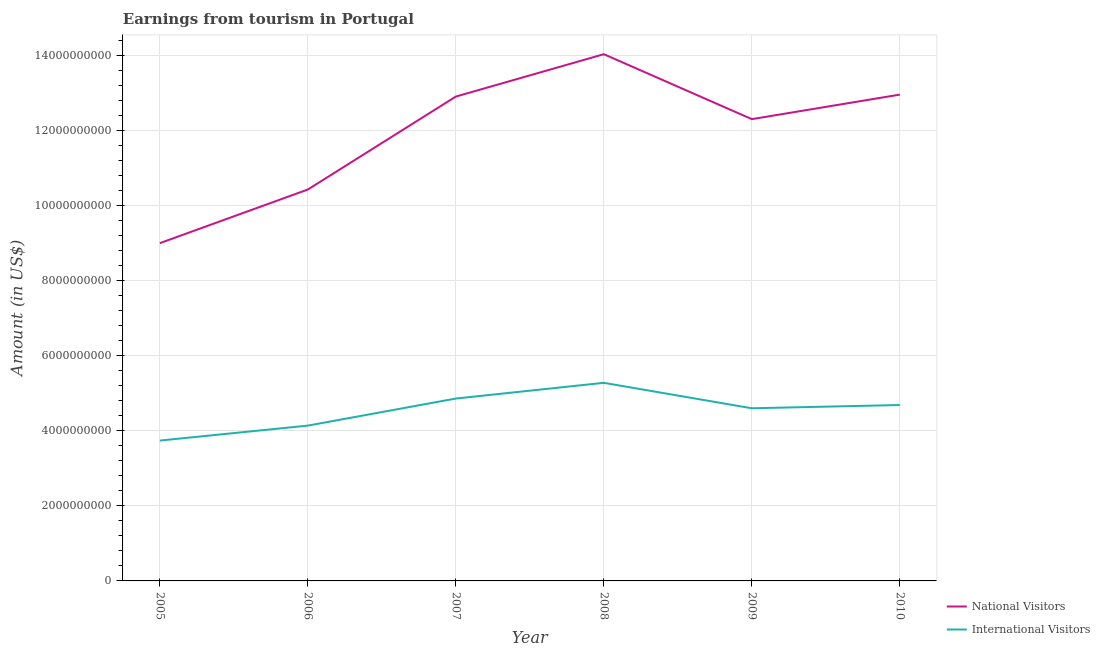Does the line corresponding to amount earned from national visitors intersect with the line corresponding to amount earned from international visitors?
Offer a terse response. No. Is the number of lines equal to the number of legend labels?
Offer a terse response. Yes. What is the amount earned from international visitors in 2006?
Your response must be concise. 4.14e+09. Across all years, what is the maximum amount earned from national visitors?
Your answer should be compact. 1.40e+1. Across all years, what is the minimum amount earned from international visitors?
Keep it short and to the point. 3.74e+09. In which year was the amount earned from international visitors maximum?
Your response must be concise. 2008. What is the total amount earned from national visitors in the graph?
Your answer should be compact. 7.17e+1. What is the difference between the amount earned from national visitors in 2005 and that in 2010?
Ensure brevity in your answer.  -3.96e+09. What is the difference between the amount earned from national visitors in 2006 and the amount earned from international visitors in 2008?
Make the answer very short. 5.16e+09. What is the average amount earned from national visitors per year?
Provide a short and direct response. 1.19e+1. In the year 2008, what is the difference between the amount earned from international visitors and amount earned from national visitors?
Offer a terse response. -8.76e+09. In how many years, is the amount earned from national visitors greater than 5200000000 US$?
Provide a succinct answer. 6. What is the ratio of the amount earned from international visitors in 2006 to that in 2010?
Keep it short and to the point. 0.88. What is the difference between the highest and the second highest amount earned from national visitors?
Provide a short and direct response. 1.08e+09. What is the difference between the highest and the lowest amount earned from national visitors?
Provide a short and direct response. 5.04e+09. Does the amount earned from international visitors monotonically increase over the years?
Keep it short and to the point. No. Is the amount earned from international visitors strictly greater than the amount earned from national visitors over the years?
Make the answer very short. No. How many lines are there?
Give a very brief answer. 2. How many years are there in the graph?
Your response must be concise. 6. Are the values on the major ticks of Y-axis written in scientific E-notation?
Your answer should be compact. No. Does the graph contain grids?
Offer a very short reply. Yes. Where does the legend appear in the graph?
Your answer should be compact. Bottom right. What is the title of the graph?
Your answer should be compact. Earnings from tourism in Portugal. Does "Primary school" appear as one of the legend labels in the graph?
Keep it short and to the point. No. What is the label or title of the X-axis?
Make the answer very short. Year. What is the Amount (in US$) of National Visitors in 2005?
Your answer should be compact. 9.01e+09. What is the Amount (in US$) in International Visitors in 2005?
Your answer should be very brief. 3.74e+09. What is the Amount (in US$) of National Visitors in 2006?
Keep it short and to the point. 1.04e+1. What is the Amount (in US$) in International Visitors in 2006?
Your answer should be compact. 4.14e+09. What is the Amount (in US$) in National Visitors in 2007?
Provide a short and direct response. 1.29e+1. What is the Amount (in US$) in International Visitors in 2007?
Provide a succinct answer. 4.86e+09. What is the Amount (in US$) in National Visitors in 2008?
Keep it short and to the point. 1.40e+1. What is the Amount (in US$) of International Visitors in 2008?
Provide a short and direct response. 5.28e+09. What is the Amount (in US$) of National Visitors in 2009?
Your answer should be very brief. 1.23e+1. What is the Amount (in US$) in International Visitors in 2009?
Your answer should be very brief. 4.60e+09. What is the Amount (in US$) of National Visitors in 2010?
Make the answer very short. 1.30e+1. What is the Amount (in US$) of International Visitors in 2010?
Make the answer very short. 4.69e+09. Across all years, what is the maximum Amount (in US$) in National Visitors?
Keep it short and to the point. 1.40e+1. Across all years, what is the maximum Amount (in US$) in International Visitors?
Offer a very short reply. 5.28e+09. Across all years, what is the minimum Amount (in US$) in National Visitors?
Your response must be concise. 9.01e+09. Across all years, what is the minimum Amount (in US$) of International Visitors?
Give a very brief answer. 3.74e+09. What is the total Amount (in US$) of National Visitors in the graph?
Keep it short and to the point. 7.17e+1. What is the total Amount (in US$) in International Visitors in the graph?
Offer a very short reply. 2.73e+1. What is the difference between the Amount (in US$) of National Visitors in 2005 and that in 2006?
Your answer should be compact. -1.43e+09. What is the difference between the Amount (in US$) in International Visitors in 2005 and that in 2006?
Ensure brevity in your answer.  -3.99e+08. What is the difference between the Amount (in US$) of National Visitors in 2005 and that in 2007?
Your response must be concise. -3.91e+09. What is the difference between the Amount (in US$) in International Visitors in 2005 and that in 2007?
Give a very brief answer. -1.12e+09. What is the difference between the Amount (in US$) of National Visitors in 2005 and that in 2008?
Offer a very short reply. -5.04e+09. What is the difference between the Amount (in US$) in International Visitors in 2005 and that in 2008?
Provide a succinct answer. -1.54e+09. What is the difference between the Amount (in US$) of National Visitors in 2005 and that in 2009?
Offer a terse response. -3.31e+09. What is the difference between the Amount (in US$) of International Visitors in 2005 and that in 2009?
Your answer should be very brief. -8.61e+08. What is the difference between the Amount (in US$) of National Visitors in 2005 and that in 2010?
Provide a short and direct response. -3.96e+09. What is the difference between the Amount (in US$) in International Visitors in 2005 and that in 2010?
Make the answer very short. -9.48e+08. What is the difference between the Amount (in US$) of National Visitors in 2006 and that in 2007?
Your answer should be very brief. -2.48e+09. What is the difference between the Amount (in US$) of International Visitors in 2006 and that in 2007?
Ensure brevity in your answer.  -7.22e+08. What is the difference between the Amount (in US$) of National Visitors in 2006 and that in 2008?
Provide a short and direct response. -3.61e+09. What is the difference between the Amount (in US$) in International Visitors in 2006 and that in 2008?
Make the answer very short. -1.14e+09. What is the difference between the Amount (in US$) of National Visitors in 2006 and that in 2009?
Provide a short and direct response. -1.88e+09. What is the difference between the Amount (in US$) in International Visitors in 2006 and that in 2009?
Ensure brevity in your answer.  -4.62e+08. What is the difference between the Amount (in US$) in National Visitors in 2006 and that in 2010?
Offer a terse response. -2.53e+09. What is the difference between the Amount (in US$) in International Visitors in 2006 and that in 2010?
Give a very brief answer. -5.49e+08. What is the difference between the Amount (in US$) of National Visitors in 2007 and that in 2008?
Your answer should be very brief. -1.13e+09. What is the difference between the Amount (in US$) of International Visitors in 2007 and that in 2008?
Keep it short and to the point. -4.19e+08. What is the difference between the Amount (in US$) in National Visitors in 2007 and that in 2009?
Offer a very short reply. 6.02e+08. What is the difference between the Amount (in US$) in International Visitors in 2007 and that in 2009?
Provide a succinct answer. 2.60e+08. What is the difference between the Amount (in US$) in National Visitors in 2007 and that in 2010?
Provide a short and direct response. -5.20e+07. What is the difference between the Amount (in US$) of International Visitors in 2007 and that in 2010?
Provide a succinct answer. 1.73e+08. What is the difference between the Amount (in US$) in National Visitors in 2008 and that in 2009?
Give a very brief answer. 1.73e+09. What is the difference between the Amount (in US$) in International Visitors in 2008 and that in 2009?
Provide a short and direct response. 6.79e+08. What is the difference between the Amount (in US$) of National Visitors in 2008 and that in 2010?
Your answer should be very brief. 1.08e+09. What is the difference between the Amount (in US$) in International Visitors in 2008 and that in 2010?
Provide a succinct answer. 5.92e+08. What is the difference between the Amount (in US$) of National Visitors in 2009 and that in 2010?
Ensure brevity in your answer.  -6.54e+08. What is the difference between the Amount (in US$) in International Visitors in 2009 and that in 2010?
Your answer should be very brief. -8.70e+07. What is the difference between the Amount (in US$) of National Visitors in 2005 and the Amount (in US$) of International Visitors in 2006?
Your answer should be compact. 4.87e+09. What is the difference between the Amount (in US$) in National Visitors in 2005 and the Amount (in US$) in International Visitors in 2007?
Make the answer very short. 4.14e+09. What is the difference between the Amount (in US$) of National Visitors in 2005 and the Amount (in US$) of International Visitors in 2008?
Provide a short and direct response. 3.72e+09. What is the difference between the Amount (in US$) in National Visitors in 2005 and the Amount (in US$) in International Visitors in 2009?
Your answer should be compact. 4.40e+09. What is the difference between the Amount (in US$) of National Visitors in 2005 and the Amount (in US$) of International Visitors in 2010?
Provide a short and direct response. 4.32e+09. What is the difference between the Amount (in US$) in National Visitors in 2006 and the Amount (in US$) in International Visitors in 2007?
Ensure brevity in your answer.  5.57e+09. What is the difference between the Amount (in US$) of National Visitors in 2006 and the Amount (in US$) of International Visitors in 2008?
Keep it short and to the point. 5.16e+09. What is the difference between the Amount (in US$) in National Visitors in 2006 and the Amount (in US$) in International Visitors in 2009?
Give a very brief answer. 5.83e+09. What is the difference between the Amount (in US$) of National Visitors in 2006 and the Amount (in US$) of International Visitors in 2010?
Your answer should be compact. 5.75e+09. What is the difference between the Amount (in US$) in National Visitors in 2007 and the Amount (in US$) in International Visitors in 2008?
Offer a terse response. 7.63e+09. What is the difference between the Amount (in US$) of National Visitors in 2007 and the Amount (in US$) of International Visitors in 2009?
Provide a succinct answer. 8.31e+09. What is the difference between the Amount (in US$) in National Visitors in 2007 and the Amount (in US$) in International Visitors in 2010?
Ensure brevity in your answer.  8.23e+09. What is the difference between the Amount (in US$) in National Visitors in 2008 and the Amount (in US$) in International Visitors in 2009?
Provide a short and direct response. 9.44e+09. What is the difference between the Amount (in US$) in National Visitors in 2008 and the Amount (in US$) in International Visitors in 2010?
Give a very brief answer. 9.36e+09. What is the difference between the Amount (in US$) of National Visitors in 2009 and the Amount (in US$) of International Visitors in 2010?
Give a very brief answer. 7.62e+09. What is the average Amount (in US$) of National Visitors per year?
Your answer should be compact. 1.19e+1. What is the average Amount (in US$) in International Visitors per year?
Provide a short and direct response. 4.55e+09. In the year 2005, what is the difference between the Amount (in US$) of National Visitors and Amount (in US$) of International Visitors?
Make the answer very short. 5.26e+09. In the year 2006, what is the difference between the Amount (in US$) in National Visitors and Amount (in US$) in International Visitors?
Keep it short and to the point. 6.30e+09. In the year 2007, what is the difference between the Amount (in US$) in National Visitors and Amount (in US$) in International Visitors?
Ensure brevity in your answer.  8.05e+09. In the year 2008, what is the difference between the Amount (in US$) in National Visitors and Amount (in US$) in International Visitors?
Your response must be concise. 8.76e+09. In the year 2009, what is the difference between the Amount (in US$) in National Visitors and Amount (in US$) in International Visitors?
Offer a very short reply. 7.71e+09. In the year 2010, what is the difference between the Amount (in US$) in National Visitors and Amount (in US$) in International Visitors?
Give a very brief answer. 8.28e+09. What is the ratio of the Amount (in US$) in National Visitors in 2005 to that in 2006?
Provide a succinct answer. 0.86. What is the ratio of the Amount (in US$) in International Visitors in 2005 to that in 2006?
Ensure brevity in your answer.  0.9. What is the ratio of the Amount (in US$) of National Visitors in 2005 to that in 2007?
Give a very brief answer. 0.7. What is the ratio of the Amount (in US$) in International Visitors in 2005 to that in 2007?
Provide a succinct answer. 0.77. What is the ratio of the Amount (in US$) of National Visitors in 2005 to that in 2008?
Provide a succinct answer. 0.64. What is the ratio of the Amount (in US$) of International Visitors in 2005 to that in 2008?
Keep it short and to the point. 0.71. What is the ratio of the Amount (in US$) in National Visitors in 2005 to that in 2009?
Your response must be concise. 0.73. What is the ratio of the Amount (in US$) in International Visitors in 2005 to that in 2009?
Provide a short and direct response. 0.81. What is the ratio of the Amount (in US$) in National Visitors in 2005 to that in 2010?
Provide a succinct answer. 0.69. What is the ratio of the Amount (in US$) of International Visitors in 2005 to that in 2010?
Offer a terse response. 0.8. What is the ratio of the Amount (in US$) of National Visitors in 2006 to that in 2007?
Keep it short and to the point. 0.81. What is the ratio of the Amount (in US$) in International Visitors in 2006 to that in 2007?
Provide a succinct answer. 0.85. What is the ratio of the Amount (in US$) of National Visitors in 2006 to that in 2008?
Your answer should be compact. 0.74. What is the ratio of the Amount (in US$) in International Visitors in 2006 to that in 2008?
Make the answer very short. 0.78. What is the ratio of the Amount (in US$) in National Visitors in 2006 to that in 2009?
Offer a terse response. 0.85. What is the ratio of the Amount (in US$) of International Visitors in 2006 to that in 2009?
Provide a short and direct response. 0.9. What is the ratio of the Amount (in US$) in National Visitors in 2006 to that in 2010?
Your answer should be compact. 0.8. What is the ratio of the Amount (in US$) of International Visitors in 2006 to that in 2010?
Give a very brief answer. 0.88. What is the ratio of the Amount (in US$) of National Visitors in 2007 to that in 2008?
Make the answer very short. 0.92. What is the ratio of the Amount (in US$) of International Visitors in 2007 to that in 2008?
Offer a very short reply. 0.92. What is the ratio of the Amount (in US$) of National Visitors in 2007 to that in 2009?
Your answer should be compact. 1.05. What is the ratio of the Amount (in US$) of International Visitors in 2007 to that in 2009?
Offer a terse response. 1.06. What is the ratio of the Amount (in US$) in National Visitors in 2007 to that in 2010?
Give a very brief answer. 1. What is the ratio of the Amount (in US$) in International Visitors in 2007 to that in 2010?
Your response must be concise. 1.04. What is the ratio of the Amount (in US$) in National Visitors in 2008 to that in 2009?
Offer a very short reply. 1.14. What is the ratio of the Amount (in US$) in International Visitors in 2008 to that in 2009?
Ensure brevity in your answer.  1.15. What is the ratio of the Amount (in US$) of National Visitors in 2008 to that in 2010?
Your response must be concise. 1.08. What is the ratio of the Amount (in US$) of International Visitors in 2008 to that in 2010?
Your answer should be compact. 1.13. What is the ratio of the Amount (in US$) in National Visitors in 2009 to that in 2010?
Offer a terse response. 0.95. What is the ratio of the Amount (in US$) in International Visitors in 2009 to that in 2010?
Keep it short and to the point. 0.98. What is the difference between the highest and the second highest Amount (in US$) in National Visitors?
Make the answer very short. 1.08e+09. What is the difference between the highest and the second highest Amount (in US$) of International Visitors?
Ensure brevity in your answer.  4.19e+08. What is the difference between the highest and the lowest Amount (in US$) of National Visitors?
Provide a succinct answer. 5.04e+09. What is the difference between the highest and the lowest Amount (in US$) of International Visitors?
Your answer should be very brief. 1.54e+09. 